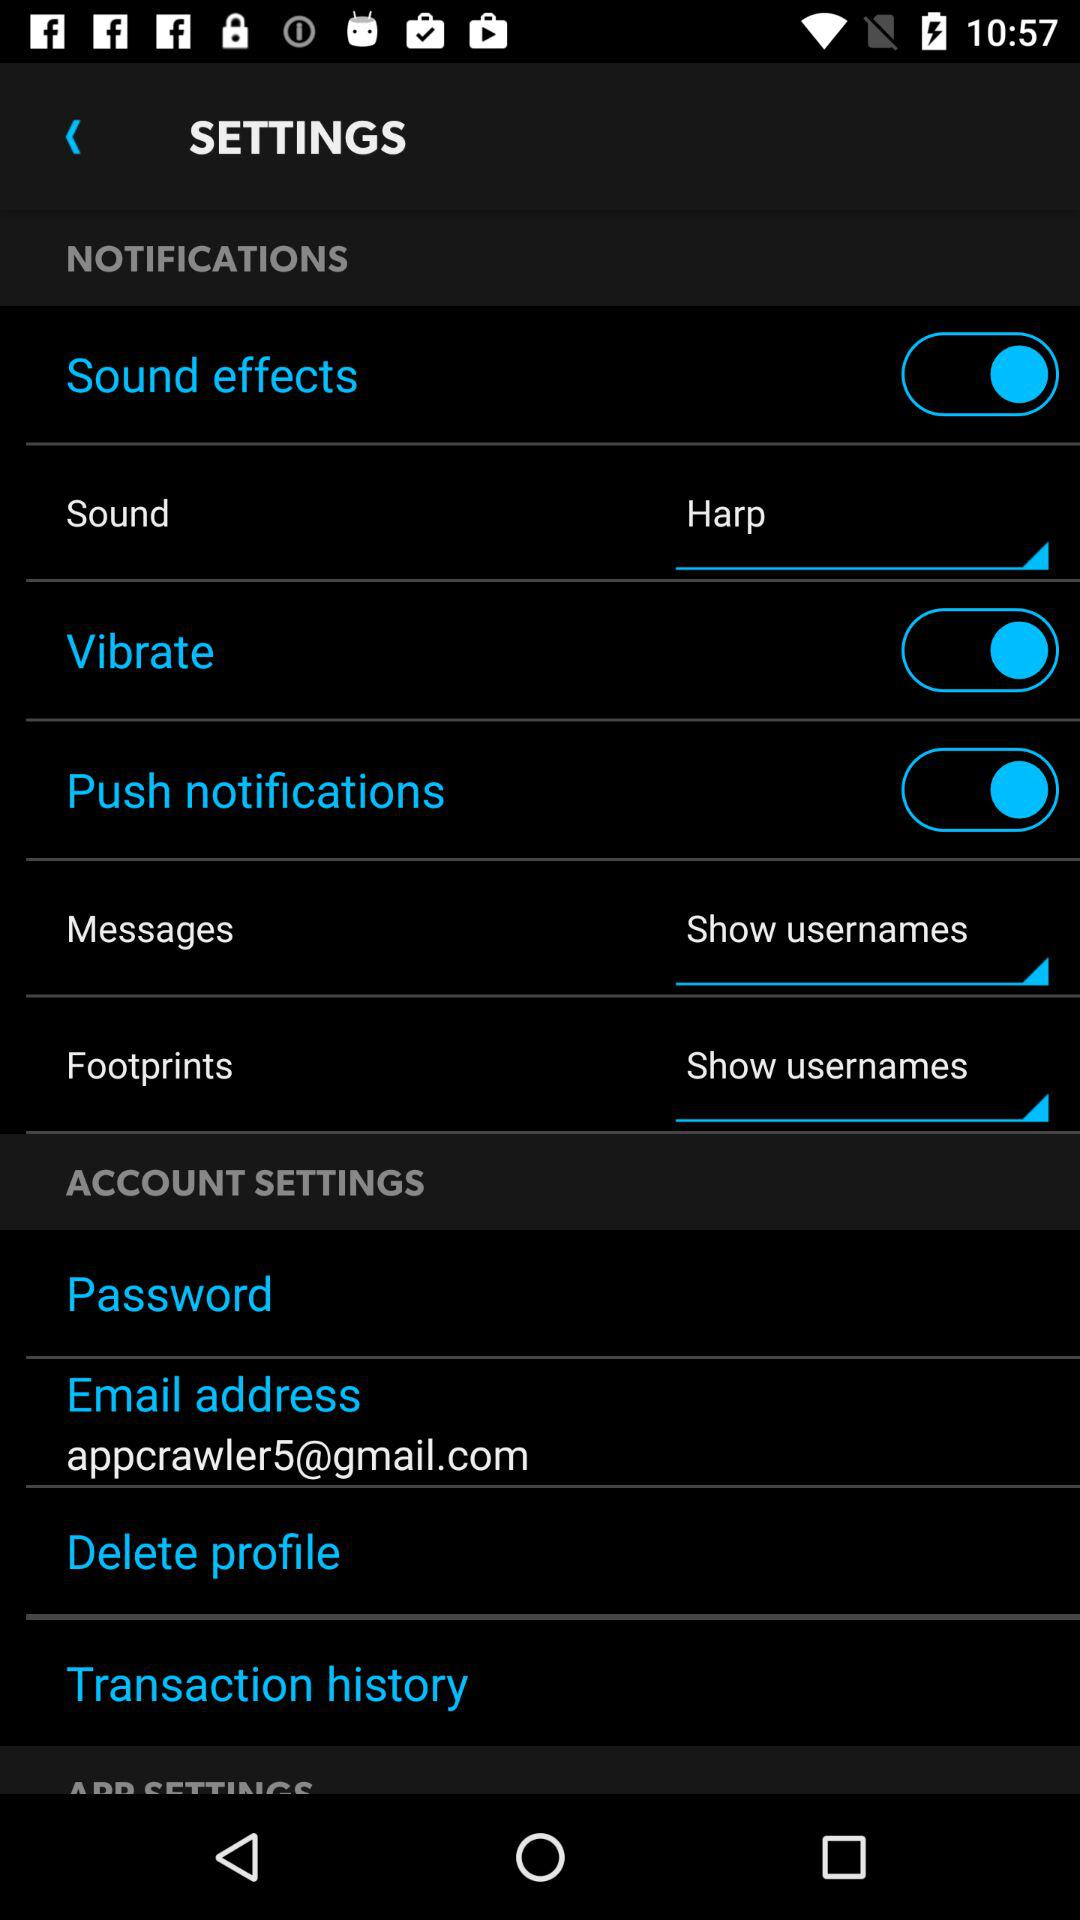Which setting is on? The settings that are on are "Sound effects", "Vibrate" and "Push notifications". 